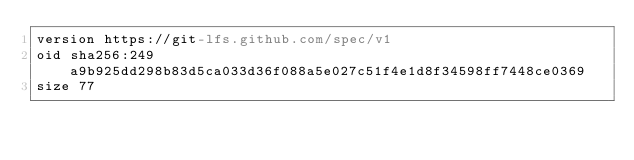Convert code to text. <code><loc_0><loc_0><loc_500><loc_500><_YAML_>version https://git-lfs.github.com/spec/v1
oid sha256:249a9b925dd298b83d5ca033d36f088a5e027c51f4e1d8f34598ff7448ce0369
size 77
</code> 